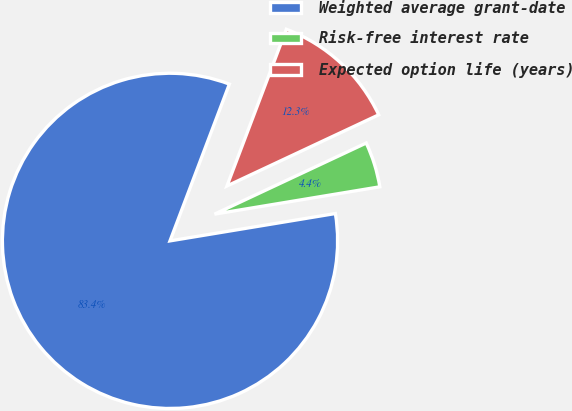Convert chart. <chart><loc_0><loc_0><loc_500><loc_500><pie_chart><fcel>Weighted average grant-date<fcel>Risk-free interest rate<fcel>Expected option life (years)<nl><fcel>83.37%<fcel>4.37%<fcel>12.26%<nl></chart> 